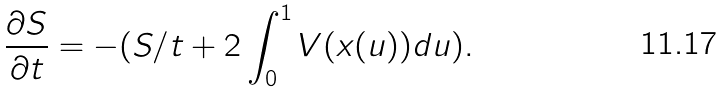<formula> <loc_0><loc_0><loc_500><loc_500>\frac { \partial S } { \partial t } = - ( S / t + 2 \int _ { 0 } ^ { 1 } V ( x ( u ) ) d u ) .</formula> 